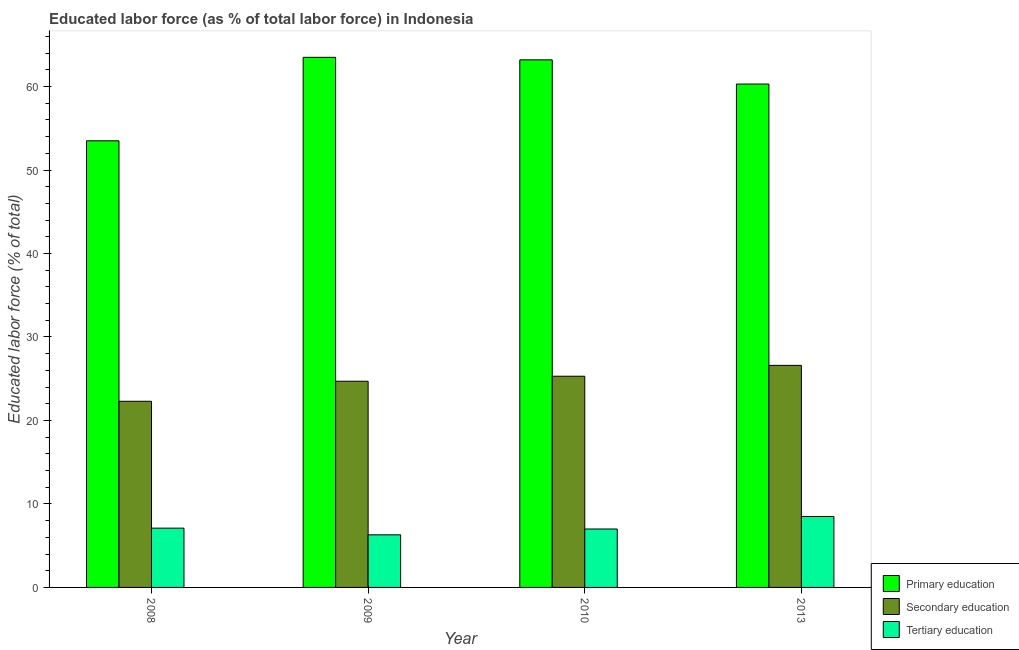How many different coloured bars are there?
Provide a short and direct response. 3. How many groups of bars are there?
Your answer should be very brief. 4. Are the number of bars per tick equal to the number of legend labels?
Your response must be concise. Yes. Are the number of bars on each tick of the X-axis equal?
Keep it short and to the point. Yes. How many bars are there on the 3rd tick from the left?
Give a very brief answer. 3. How many bars are there on the 4th tick from the right?
Your answer should be very brief. 3. In how many cases, is the number of bars for a given year not equal to the number of legend labels?
Ensure brevity in your answer.  0. What is the percentage of labor force who received secondary education in 2008?
Your response must be concise. 22.3. Across all years, what is the maximum percentage of labor force who received secondary education?
Provide a short and direct response. 26.6. Across all years, what is the minimum percentage of labor force who received tertiary education?
Ensure brevity in your answer.  6.3. In which year was the percentage of labor force who received tertiary education minimum?
Your answer should be compact. 2009. What is the total percentage of labor force who received tertiary education in the graph?
Your response must be concise. 28.9. What is the difference between the percentage of labor force who received primary education in 2008 and that in 2013?
Give a very brief answer. -6.8. What is the difference between the percentage of labor force who received tertiary education in 2008 and the percentage of labor force who received secondary education in 2009?
Offer a terse response. 0.8. What is the average percentage of labor force who received tertiary education per year?
Provide a succinct answer. 7.23. What is the ratio of the percentage of labor force who received primary education in 2008 to that in 2013?
Keep it short and to the point. 0.89. Is the percentage of labor force who received primary education in 2008 less than that in 2009?
Your response must be concise. Yes. Is the difference between the percentage of labor force who received tertiary education in 2010 and 2013 greater than the difference between the percentage of labor force who received primary education in 2010 and 2013?
Provide a succinct answer. No. What is the difference between the highest and the second highest percentage of labor force who received secondary education?
Your answer should be very brief. 1.3. What is the difference between the highest and the lowest percentage of labor force who received secondary education?
Keep it short and to the point. 4.3. What does the 2nd bar from the left in 2009 represents?
Keep it short and to the point. Secondary education. What does the 1st bar from the right in 2010 represents?
Keep it short and to the point. Tertiary education. How many bars are there?
Provide a succinct answer. 12. Are the values on the major ticks of Y-axis written in scientific E-notation?
Provide a short and direct response. No. Where does the legend appear in the graph?
Your answer should be very brief. Bottom right. How are the legend labels stacked?
Your response must be concise. Vertical. What is the title of the graph?
Offer a terse response. Educated labor force (as % of total labor force) in Indonesia. What is the label or title of the Y-axis?
Make the answer very short. Educated labor force (% of total). What is the Educated labor force (% of total) in Primary education in 2008?
Your answer should be very brief. 53.5. What is the Educated labor force (% of total) of Secondary education in 2008?
Your answer should be very brief. 22.3. What is the Educated labor force (% of total) of Tertiary education in 2008?
Provide a succinct answer. 7.1. What is the Educated labor force (% of total) of Primary education in 2009?
Your response must be concise. 63.5. What is the Educated labor force (% of total) of Secondary education in 2009?
Make the answer very short. 24.7. What is the Educated labor force (% of total) of Tertiary education in 2009?
Provide a succinct answer. 6.3. What is the Educated labor force (% of total) in Primary education in 2010?
Make the answer very short. 63.2. What is the Educated labor force (% of total) in Secondary education in 2010?
Provide a short and direct response. 25.3. What is the Educated labor force (% of total) in Tertiary education in 2010?
Offer a very short reply. 7. What is the Educated labor force (% of total) in Primary education in 2013?
Make the answer very short. 60.3. What is the Educated labor force (% of total) of Secondary education in 2013?
Offer a terse response. 26.6. What is the Educated labor force (% of total) in Tertiary education in 2013?
Offer a terse response. 8.5. Across all years, what is the maximum Educated labor force (% of total) of Primary education?
Keep it short and to the point. 63.5. Across all years, what is the maximum Educated labor force (% of total) in Secondary education?
Provide a succinct answer. 26.6. Across all years, what is the minimum Educated labor force (% of total) in Primary education?
Make the answer very short. 53.5. Across all years, what is the minimum Educated labor force (% of total) in Secondary education?
Your response must be concise. 22.3. Across all years, what is the minimum Educated labor force (% of total) in Tertiary education?
Your answer should be compact. 6.3. What is the total Educated labor force (% of total) in Primary education in the graph?
Give a very brief answer. 240.5. What is the total Educated labor force (% of total) of Secondary education in the graph?
Your answer should be compact. 98.9. What is the total Educated labor force (% of total) in Tertiary education in the graph?
Provide a succinct answer. 28.9. What is the difference between the Educated labor force (% of total) of Primary education in 2008 and that in 2009?
Offer a terse response. -10. What is the difference between the Educated labor force (% of total) of Secondary education in 2008 and that in 2009?
Provide a succinct answer. -2.4. What is the difference between the Educated labor force (% of total) of Tertiary education in 2008 and that in 2009?
Offer a terse response. 0.8. What is the difference between the Educated labor force (% of total) of Secondary education in 2008 and that in 2010?
Provide a short and direct response. -3. What is the difference between the Educated labor force (% of total) of Tertiary education in 2008 and that in 2010?
Keep it short and to the point. 0.1. What is the difference between the Educated labor force (% of total) in Secondary education in 2008 and that in 2013?
Your answer should be very brief. -4.3. What is the difference between the Educated labor force (% of total) in Tertiary education in 2008 and that in 2013?
Your answer should be very brief. -1.4. What is the difference between the Educated labor force (% of total) of Primary education in 2009 and that in 2010?
Offer a very short reply. 0.3. What is the difference between the Educated labor force (% of total) in Secondary education in 2009 and that in 2010?
Your answer should be very brief. -0.6. What is the difference between the Educated labor force (% of total) in Primary education in 2009 and that in 2013?
Keep it short and to the point. 3.2. What is the difference between the Educated labor force (% of total) in Secondary education in 2009 and that in 2013?
Your answer should be compact. -1.9. What is the difference between the Educated labor force (% of total) of Primary education in 2010 and that in 2013?
Offer a very short reply. 2.9. What is the difference between the Educated labor force (% of total) of Secondary education in 2010 and that in 2013?
Your answer should be compact. -1.3. What is the difference between the Educated labor force (% of total) of Tertiary education in 2010 and that in 2013?
Make the answer very short. -1.5. What is the difference between the Educated labor force (% of total) of Primary education in 2008 and the Educated labor force (% of total) of Secondary education in 2009?
Provide a succinct answer. 28.8. What is the difference between the Educated labor force (% of total) in Primary education in 2008 and the Educated labor force (% of total) in Tertiary education in 2009?
Make the answer very short. 47.2. What is the difference between the Educated labor force (% of total) in Primary education in 2008 and the Educated labor force (% of total) in Secondary education in 2010?
Provide a succinct answer. 28.2. What is the difference between the Educated labor force (% of total) of Primary education in 2008 and the Educated labor force (% of total) of Tertiary education in 2010?
Give a very brief answer. 46.5. What is the difference between the Educated labor force (% of total) in Primary education in 2008 and the Educated labor force (% of total) in Secondary education in 2013?
Give a very brief answer. 26.9. What is the difference between the Educated labor force (% of total) of Secondary education in 2008 and the Educated labor force (% of total) of Tertiary education in 2013?
Your answer should be very brief. 13.8. What is the difference between the Educated labor force (% of total) in Primary education in 2009 and the Educated labor force (% of total) in Secondary education in 2010?
Your answer should be compact. 38.2. What is the difference between the Educated labor force (% of total) in Primary education in 2009 and the Educated labor force (% of total) in Tertiary education in 2010?
Keep it short and to the point. 56.5. What is the difference between the Educated labor force (% of total) of Secondary education in 2009 and the Educated labor force (% of total) of Tertiary education in 2010?
Provide a short and direct response. 17.7. What is the difference between the Educated labor force (% of total) of Primary education in 2009 and the Educated labor force (% of total) of Secondary education in 2013?
Offer a very short reply. 36.9. What is the difference between the Educated labor force (% of total) of Primary education in 2009 and the Educated labor force (% of total) of Tertiary education in 2013?
Make the answer very short. 55. What is the difference between the Educated labor force (% of total) in Secondary education in 2009 and the Educated labor force (% of total) in Tertiary education in 2013?
Keep it short and to the point. 16.2. What is the difference between the Educated labor force (% of total) of Primary education in 2010 and the Educated labor force (% of total) of Secondary education in 2013?
Ensure brevity in your answer.  36.6. What is the difference between the Educated labor force (% of total) in Primary education in 2010 and the Educated labor force (% of total) in Tertiary education in 2013?
Offer a terse response. 54.7. What is the difference between the Educated labor force (% of total) in Secondary education in 2010 and the Educated labor force (% of total) in Tertiary education in 2013?
Your answer should be very brief. 16.8. What is the average Educated labor force (% of total) in Primary education per year?
Offer a very short reply. 60.12. What is the average Educated labor force (% of total) of Secondary education per year?
Offer a very short reply. 24.73. What is the average Educated labor force (% of total) of Tertiary education per year?
Offer a very short reply. 7.22. In the year 2008, what is the difference between the Educated labor force (% of total) of Primary education and Educated labor force (% of total) of Secondary education?
Make the answer very short. 31.2. In the year 2008, what is the difference between the Educated labor force (% of total) in Primary education and Educated labor force (% of total) in Tertiary education?
Provide a succinct answer. 46.4. In the year 2009, what is the difference between the Educated labor force (% of total) of Primary education and Educated labor force (% of total) of Secondary education?
Offer a very short reply. 38.8. In the year 2009, what is the difference between the Educated labor force (% of total) in Primary education and Educated labor force (% of total) in Tertiary education?
Your answer should be very brief. 57.2. In the year 2010, what is the difference between the Educated labor force (% of total) in Primary education and Educated labor force (% of total) in Secondary education?
Your answer should be very brief. 37.9. In the year 2010, what is the difference between the Educated labor force (% of total) of Primary education and Educated labor force (% of total) of Tertiary education?
Provide a succinct answer. 56.2. In the year 2013, what is the difference between the Educated labor force (% of total) in Primary education and Educated labor force (% of total) in Secondary education?
Offer a terse response. 33.7. In the year 2013, what is the difference between the Educated labor force (% of total) in Primary education and Educated labor force (% of total) in Tertiary education?
Make the answer very short. 51.8. What is the ratio of the Educated labor force (% of total) of Primary education in 2008 to that in 2009?
Provide a succinct answer. 0.84. What is the ratio of the Educated labor force (% of total) of Secondary education in 2008 to that in 2009?
Keep it short and to the point. 0.9. What is the ratio of the Educated labor force (% of total) of Tertiary education in 2008 to that in 2009?
Make the answer very short. 1.13. What is the ratio of the Educated labor force (% of total) in Primary education in 2008 to that in 2010?
Your answer should be very brief. 0.85. What is the ratio of the Educated labor force (% of total) in Secondary education in 2008 to that in 2010?
Your response must be concise. 0.88. What is the ratio of the Educated labor force (% of total) in Tertiary education in 2008 to that in 2010?
Offer a very short reply. 1.01. What is the ratio of the Educated labor force (% of total) of Primary education in 2008 to that in 2013?
Keep it short and to the point. 0.89. What is the ratio of the Educated labor force (% of total) in Secondary education in 2008 to that in 2013?
Make the answer very short. 0.84. What is the ratio of the Educated labor force (% of total) of Tertiary education in 2008 to that in 2013?
Keep it short and to the point. 0.84. What is the ratio of the Educated labor force (% of total) in Secondary education in 2009 to that in 2010?
Give a very brief answer. 0.98. What is the ratio of the Educated labor force (% of total) in Primary education in 2009 to that in 2013?
Ensure brevity in your answer.  1.05. What is the ratio of the Educated labor force (% of total) of Tertiary education in 2009 to that in 2013?
Make the answer very short. 0.74. What is the ratio of the Educated labor force (% of total) of Primary education in 2010 to that in 2013?
Provide a short and direct response. 1.05. What is the ratio of the Educated labor force (% of total) of Secondary education in 2010 to that in 2013?
Make the answer very short. 0.95. What is the ratio of the Educated labor force (% of total) in Tertiary education in 2010 to that in 2013?
Offer a very short reply. 0.82. What is the difference between the highest and the second highest Educated labor force (% of total) in Secondary education?
Keep it short and to the point. 1.3. What is the difference between the highest and the lowest Educated labor force (% of total) in Secondary education?
Make the answer very short. 4.3. 